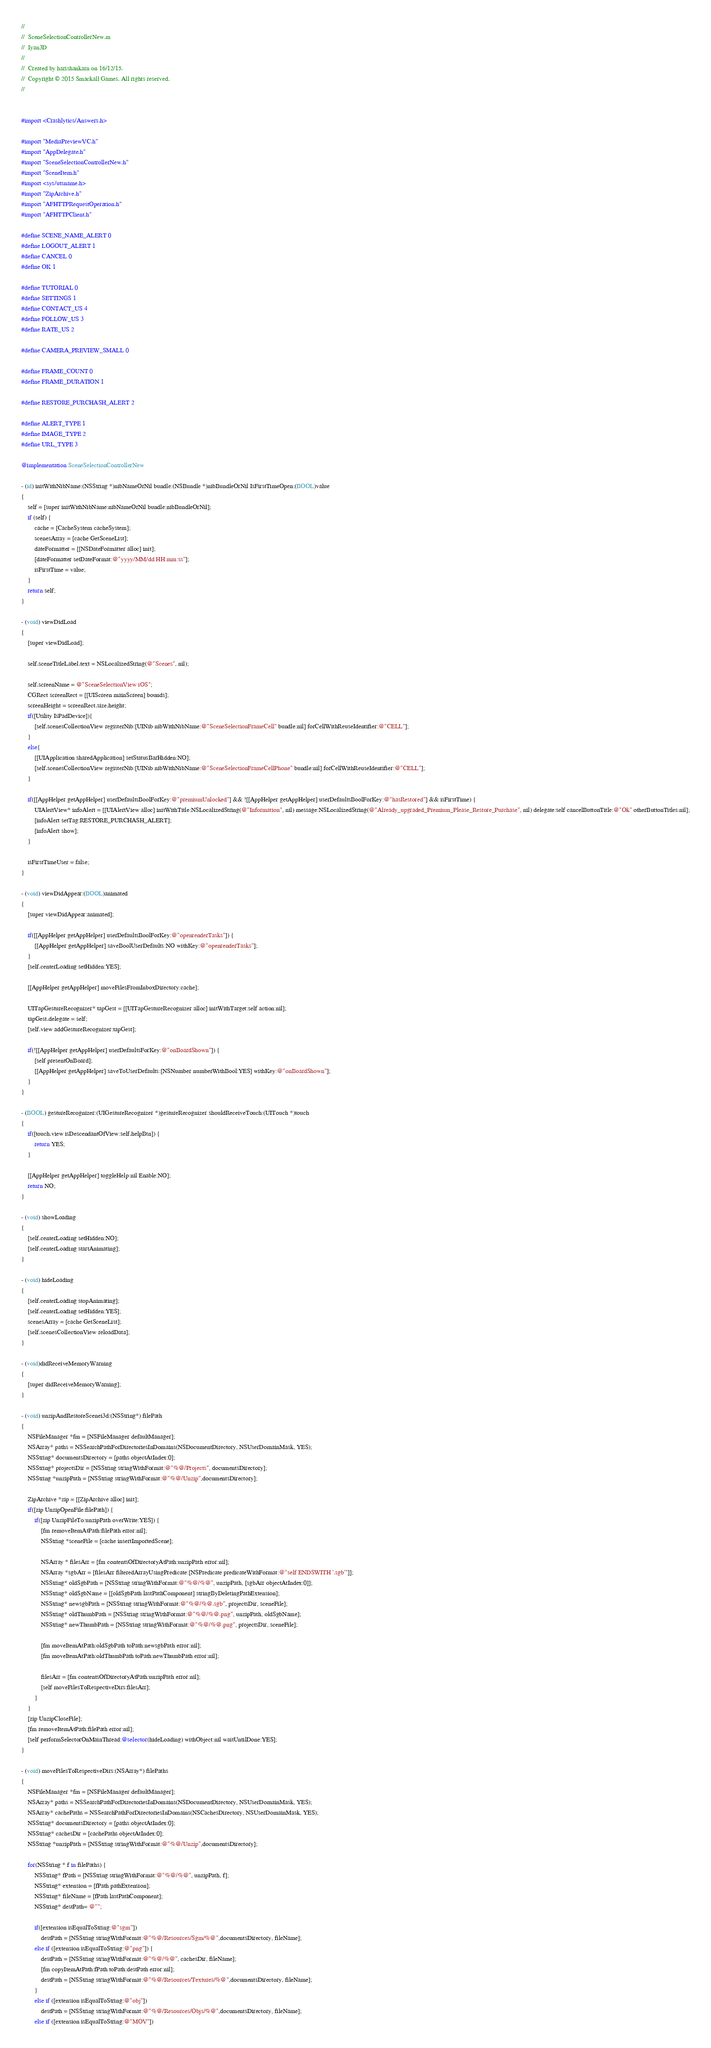Convert code to text. <code><loc_0><loc_0><loc_500><loc_500><_ObjectiveC_>//
//  SceneSelectionControllerNew.m
//  Iyan3D
//
//  Created by harishankarn on 16/12/15.
//  Copyright © 2015 Smackall Games. All rights reserved.
//


#import <Crashlytics/Answers.h>

#import "MediaPreviewVC.h"
#import "AppDelegate.h"
#import "SceneSelectionControllerNew.h"
#import "SceneItem.h"
#import <sys/utsname.h>
#import "ZipArchive.h"
#import "AFHTTPRequestOperation.h"
#import "AFHTTPClient.h"

#define SCENE_NAME_ALERT 0
#define LOGOUT_ALERT 1
#define CANCEL 0
#define OK 1

#define TUTORIAL 0
#define SETTINGS 1
#define CONTACT_US 4
#define FOLLOW_US 3
#define RATE_US 2

#define CAMERA_PREVIEW_SMALL 0

#define FRAME_COUNT 0
#define FRAME_DURATION 1

#define RESTORE_PURCHASH_ALERT 2

#define ALERT_TYPE 1
#define IMAGE_TYPE 2
#define URL_TYPE 3

@implementation SceneSelectionControllerNew

- (id) initWithNibName:(NSString *)nibNameOrNil bundle:(NSBundle *)nibBundleOrNil IsFirstTimeOpen:(BOOL)value
{
    self = [super initWithNibName:nibNameOrNil bundle:nibBundleOrNil];
    if (self) {
        cache = [CacheSystem cacheSystem];
        scenesArray = [cache GetSceneList];
        dateFormatter = [[NSDateFormatter alloc] init];
        [dateFormatter setDateFormat:@"yyyy/MM/dd HH:mm:ss"];
        isFirstTime = value;
    }
    return self;
}

- (void) viewDidLoad
{
    [super viewDidLoad];
    
    self.sceneTitleLabel.text = NSLocalizedString(@"Scenes", nil);
    
    self.screenName = @"SceneSelectionView iOS";
    CGRect screenRect = [[UIScreen mainScreen] bounds];
    screenHeight = screenRect.size.height;
    if([Utility IsPadDevice]){
        [self.scenesCollectionView registerNib:[UINib nibWithNibName:@"SceneSelectionFrameCell" bundle:nil] forCellWithReuseIdentifier:@"CELL"];
    }
    else{
        [[UIApplication sharedApplication] setStatusBarHidden:NO];
        [self.scenesCollectionView registerNib:[UINib nibWithNibName:@"SceneSelectionFrameCellPhone" bundle:nil] forCellWithReuseIdentifier:@"CELL"];
    }
    
    if([[AppHelper getAppHelper] userDefaultsBoolForKey:@"premiumUnlocked"] && ![[AppHelper getAppHelper] userDefaultsBoolForKey:@"hasRestored"] && isFirstTime) {
        UIAlertView* infoAlert = [[UIAlertView alloc] initWithTitle:NSLocalizedString(@"Information", nil) message:NSLocalizedString(@"Already_upgraded_Premium_Please_Restore_Purchase", nil) delegate:self cancelButtonTitle:@"Ok" otherButtonTitles:nil];
        [infoAlert setTag:RESTORE_PURCHASH_ALERT];
        [infoAlert show];
    }
    
    isFirstTimeUser = false;
}

- (void) viewDidAppear:(BOOL)animated
{
    [super viewDidAppear:animated];
    
    if([[AppHelper getAppHelper] userDefaultsBoolForKey:@"openrenderTasks"]) {
        [[AppHelper getAppHelper] saveBoolUserDefaults:NO withKey:@"openrenderTasks"];
    }
    [self.centerLoading setHidden:YES];
    
    [[AppHelper getAppHelper] moveFilesFromInboxDirectory:cache];
    
    UITapGestureRecognizer* tapGest = [[UITapGestureRecognizer alloc] initWithTarget:self action:nil];
    tapGest.delegate = self;
    [self.view addGestureRecognizer:tapGest];
    
    if(![[AppHelper getAppHelper] userDefaultsForKey:@"onBoardShown"]) {
        [self presentOnBoard];
        [[AppHelper getAppHelper] saveToUserDefaults:[NSNumber numberWithBool:YES] withKey:@"onBoardShown"];
    }
}

- (BOOL) gestureRecognizer:(UIGestureRecognizer *)gestureRecognizer shouldReceiveTouch:(UITouch *)touch
{
    if([touch.view isDescendantOfView:self.helpBtn]) {
        return YES;
    }
    
    [[AppHelper getAppHelper] toggleHelp:nil Enable:NO];
    return NO;
}

- (void) showLoading
{
    [self.centerLoading setHidden:NO];
    [self.centerLoading startAnimating];
}

- (void) hideLoading
{
    [self.centerLoading stopAnimating];
    [self.centerLoading setHidden:YES];
    scenesArray = [cache GetSceneList];
    [self.scenesCollectionView reloadData];
}

- (void)didReceiveMemoryWarning
{
    [super didReceiveMemoryWarning];
}

- (void) unzipAndRestoreScenei3d:(NSString*) filePath
{
    NSFileManager *fm = [NSFileManager defaultManager];
    NSArray* paths = NSSearchPathForDirectoriesInDomains(NSDocumentDirectory, NSUserDomainMask, YES);
    NSString* documentsDirectory = [paths objectAtIndex:0];
    NSString* projectsDir = [NSString stringWithFormat:@"%@/Projects", documentsDirectory];
    NSString *unzipPath = [NSString stringWithFormat:@"%@/Unzip",documentsDirectory];

    ZipArchive *zip = [[ZipArchive alloc] init];
    if([zip UnzipOpenFile:filePath]) {
        if([zip UnzipFileTo:unzipPath overWrite:YES]) {
            [fm removeItemAtPath:filePath error:nil];
            NSString *sceneFile = [cache insertImportedScene];
    
            NSArray * filesArr = [fm contentsOfDirectoryAtPath:unzipPath error:nil];
            NSArray *sgbArr = [filesArr filteredArrayUsingPredicate:[NSPredicate predicateWithFormat:@"self ENDSWITH '.sgb'"]];
            NSString* oldSgbPath = [NSString stringWithFormat:@"%@/%@", unzipPath, [sgbArr objectAtIndex:0]];
            NSString* oldSgbName = [[oldSgbPath lastPathComponent] stringByDeletingPathExtension];
            NSString* newsgbPath = [NSString stringWithFormat:@"%@/%@.sgb", projectsDir, sceneFile];
            NSString* oldThumbPath = [NSString stringWithFormat:@"%@/%@.png", unzipPath, oldSgbName];
            NSString* newThumbPath = [NSString stringWithFormat:@"%@/%@.png", projectsDir, sceneFile];
            
            [fm moveItemAtPath:oldSgbPath toPath:newsgbPath error:nil];
            [fm moveItemAtPath:oldThumbPath toPath:newThumbPath error:nil];
            
            filesArr = [fm contentsOfDirectoryAtPath:unzipPath error:nil];
            [self moveFilesToRespectiveDirs:filesArr];
        }
    }
    [zip UnzipCloseFile];
    [fm removeItemAtPath:filePath error:nil];
    [self performSelectorOnMainThread:@selector(hideLoading) withObject:nil waitUntilDone:YES];
}

- (void) moveFilesToRespectiveDirs:(NSArray*) filePaths
{
    NSFileManager *fm = [NSFileManager defaultManager];
    NSArray* paths = NSSearchPathForDirectoriesInDomains(NSDocumentDirectory, NSUserDomainMask, YES);
    NSArray* cachePaths = NSSearchPathForDirectoriesInDomains(NSCachesDirectory, NSUserDomainMask, YES);
    NSString* documentsDirectory = [paths objectAtIndex:0];
    NSString* cachesDir = [cachePaths objectAtIndex:0];
    NSString *unzipPath = [NSString stringWithFormat:@"%@/Unzip",documentsDirectory];

    for(NSString * f in filePaths) {
        NSString* fPath = [NSString stringWithFormat:@"%@/%@", unzipPath, f];
        NSString* extension = [fPath pathExtension];
        NSString* fileName = [fPath lastPathComponent];
        NSString* destPath= @"";
        
        if([extension isEqualToString:@"sgm"])
            destPath = [NSString stringWithFormat:@"%@/Resources/Sgm/%@",documentsDirectory, fileName];
        else if ([extension isEqualToString:@"png"]) {
            destPath = [NSString stringWithFormat:@"%@/%@", cachesDir, fileName];
            [fm copyItemAtPath:fPath toPath:destPath error:nil];
            destPath = [NSString stringWithFormat:@"%@/Resources/Textures/%@",documentsDirectory, fileName];
        }
        else if ([extension isEqualToString:@"obj"])
            destPath = [NSString stringWithFormat:@"%@/Resources/Objs/%@",documentsDirectory, fileName];
        else if ([extension isEqualToString:@"MOV"])</code> 